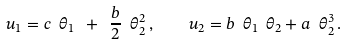<formula> <loc_0><loc_0><loc_500><loc_500>u _ { 1 } = c \ \theta _ { 1 } \ + \ \frac { b } { 2 } \ \theta ^ { 2 } _ { 2 } \, , \quad u _ { 2 } = b \ \theta _ { 1 } \ \theta _ { 2 } + a \ \theta _ { 2 } ^ { 3 } \, .</formula> 